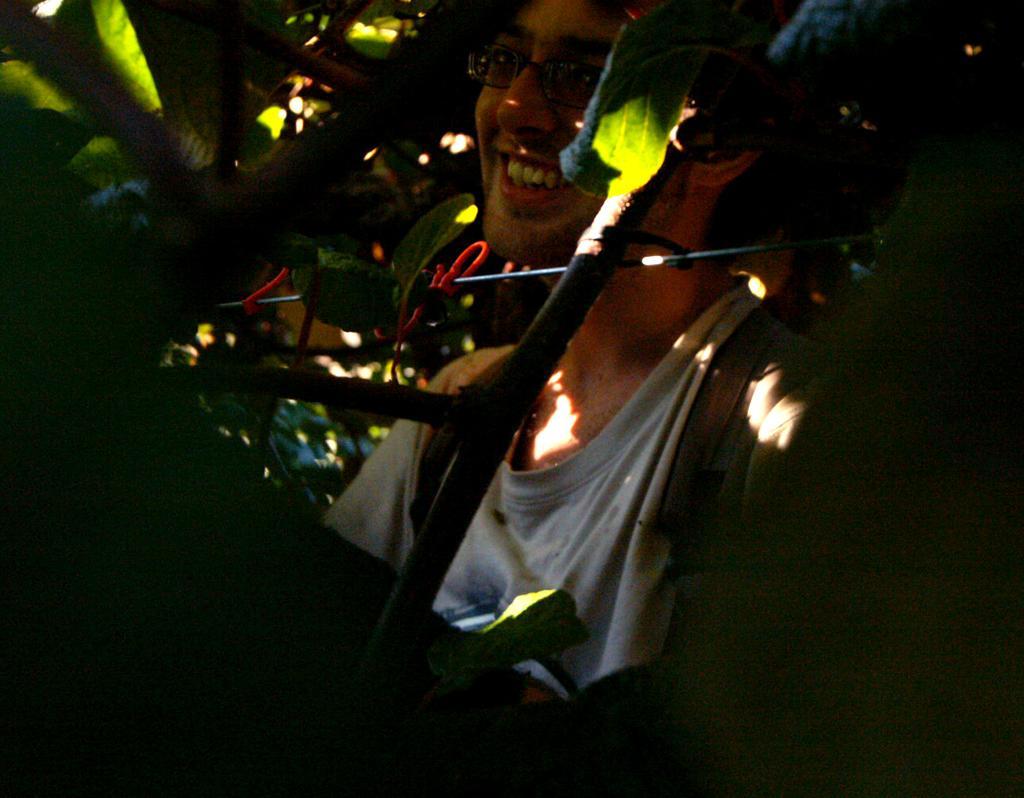How would you summarize this image in a sentence or two? In this picture there is a man who is wearing t-shirt and spectacle. He is sitting near to the plants. In the bottom left corner I can see the darkness. 